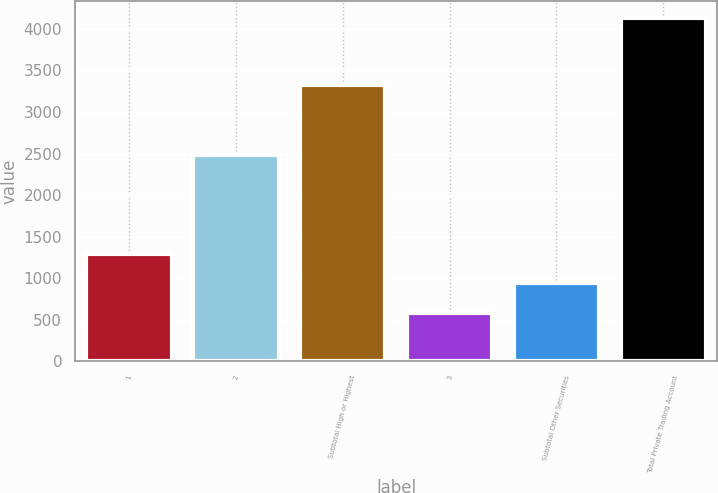<chart> <loc_0><loc_0><loc_500><loc_500><bar_chart><fcel>1<fcel>2<fcel>Subtotal High or Highest<fcel>3<fcel>Subtotal Other Securities<fcel>Total Private Trading Account<nl><fcel>1294<fcel>2477<fcel>3330<fcel>585<fcel>939.5<fcel>4130<nl></chart> 